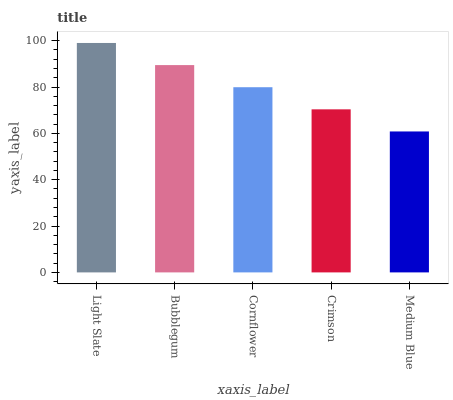Is Bubblegum the minimum?
Answer yes or no. No. Is Bubblegum the maximum?
Answer yes or no. No. Is Light Slate greater than Bubblegum?
Answer yes or no. Yes. Is Bubblegum less than Light Slate?
Answer yes or no. Yes. Is Bubblegum greater than Light Slate?
Answer yes or no. No. Is Light Slate less than Bubblegum?
Answer yes or no. No. Is Cornflower the high median?
Answer yes or no. Yes. Is Cornflower the low median?
Answer yes or no. Yes. Is Bubblegum the high median?
Answer yes or no. No. Is Crimson the low median?
Answer yes or no. No. 